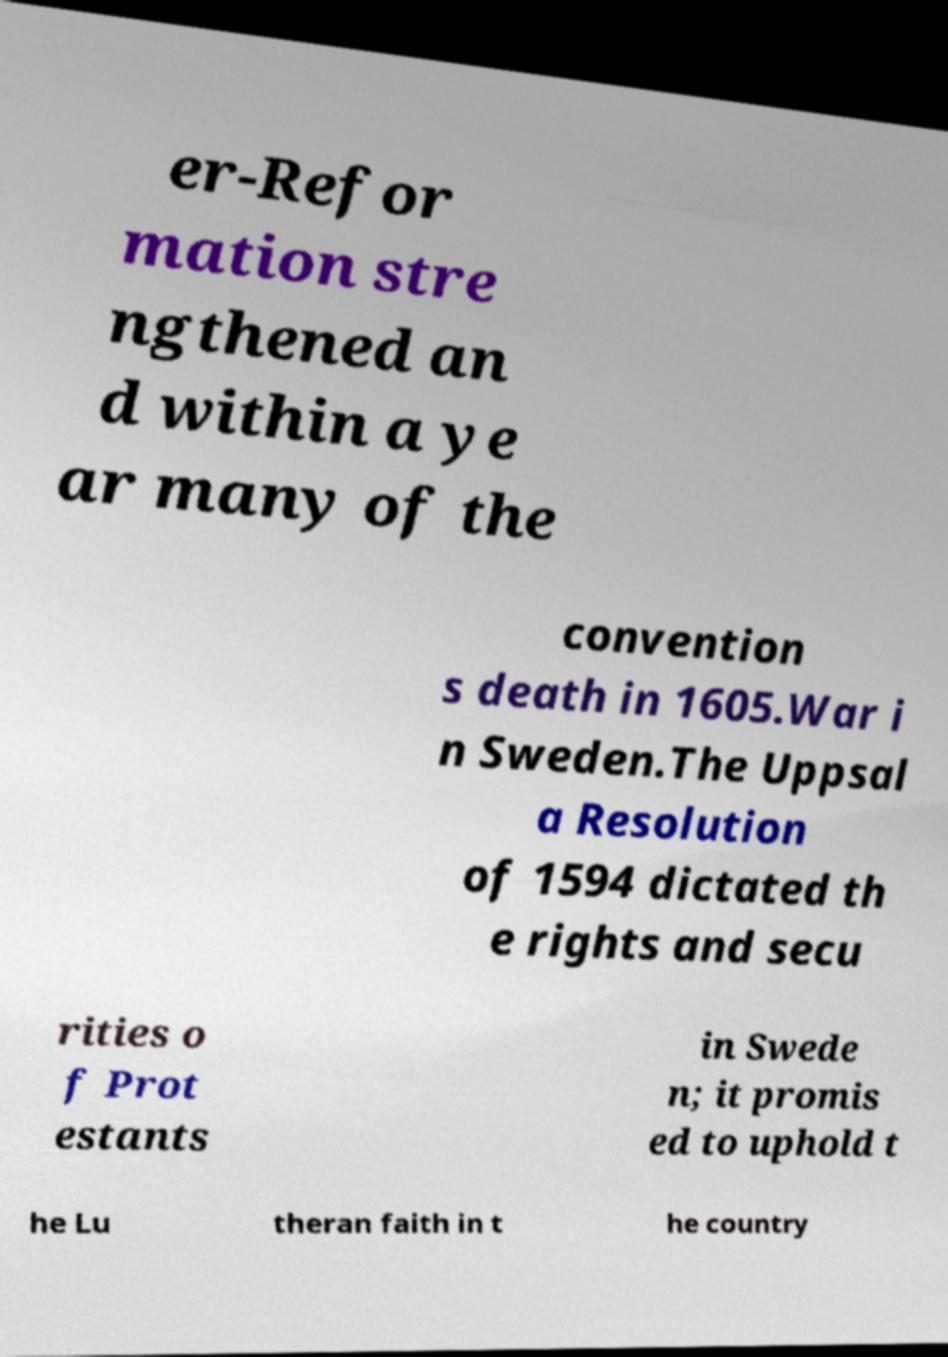Can you accurately transcribe the text from the provided image for me? er-Refor mation stre ngthened an d within a ye ar many of the convention s death in 1605.War i n Sweden.The Uppsal a Resolution of 1594 dictated th e rights and secu rities o f Prot estants in Swede n; it promis ed to uphold t he Lu theran faith in t he country 